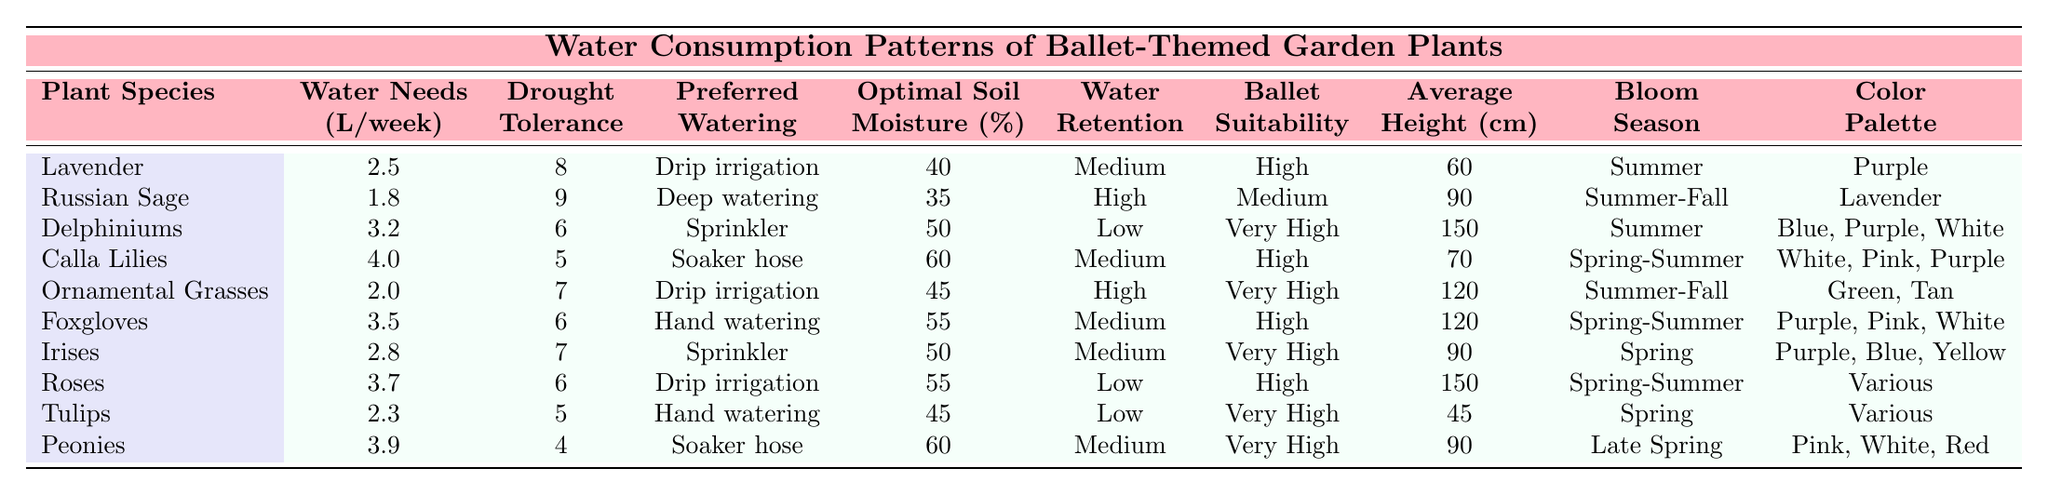What is the water need of Calla Lilies in liters per week? The table shows that the water need for Calla Lilies is 4.0 liters per week.
Answer: 4.0 Which plant species has the highest drought tolerance score? By examining the drought tolerance scores, Russian Sage has the highest score of 9.
Answer: Russian Sage What is the average height of the plants listed in the table? The average height can be calculated by summing all heights: (60 + 90 + 150 + 70 + 120 + 120 + 90 + 150 + 45 + 90) = 1055 cm; then divide by 10 plants: 1055 / 10 = 105.5 cm.
Answer: 105.5 cm Which watering method is preferred for Roses? According to the table, the preferred watering method for Roses is drip irrigation.
Answer: Drip irrigation What is the drought tolerance score of Peonies? The table indicates that Peonies have a drought tolerance score of 4.
Answer: 4 Which plant has the least water retention ability? The data shows that Delphiniums and Roses both have a low water retention ability.
Answer: Delphiniums and Roses What's the difference in water needs between Delphiniums and Lavender? Delphiniums need 3.2 liters per week and Lavender needs 2.5 liters; the difference is 3.2 - 2.5 = 0.7 liters.
Answer: 0.7 liters Do any plants have a "Very High" suitability for ballet-inspired arrangements? Yes, according to the table, Delphiniums, Ornamental Grasses, Irises, Tulips, and Peonies all have a "Very High" suitability.
Answer: Yes Which watering method is most common among the plants listed? The most common watering method is drip irrigation, as it is used by Lavender, Ornamental Grasses, and Roses.
Answer: Drip irrigation How many plants have water needs greater than 3 liters per week? By reviewing the water needs, the plants with over 3 liters per week are Delphiniums (3.2), Calla Lilies (4.0), Foxgloves (3.5), and Peonies (3.9). This totals to 4 plants.
Answer: 4 plants 